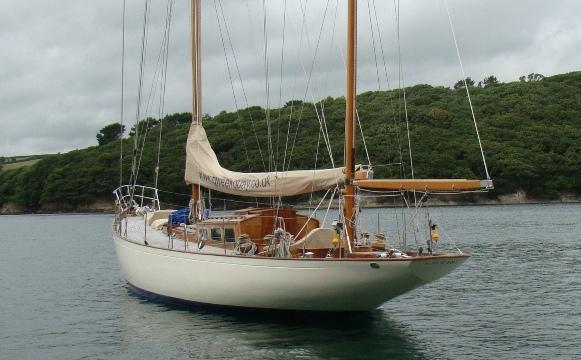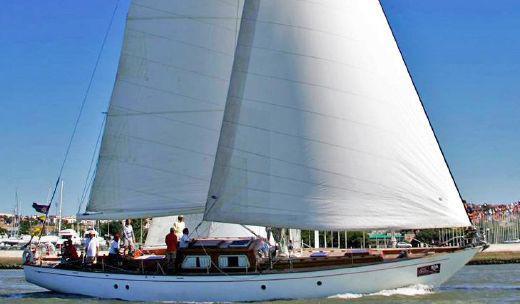The first image is the image on the left, the second image is the image on the right. Assess this claim about the two images: "One image in the pair shows the boat's sails up, the other image shows the sails folded down.". Correct or not? Answer yes or no. Yes. The first image is the image on the left, the second image is the image on the right. Given the left and right images, does the statement "In at least one image there is a boat with 3 sails raised" hold true? Answer yes or no. No. 